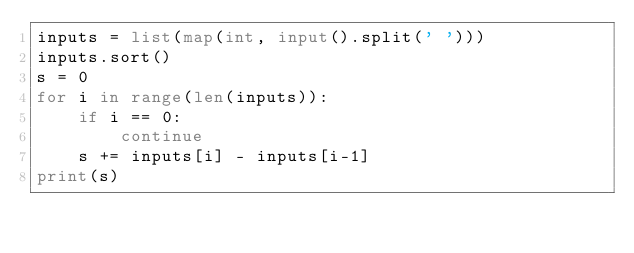<code> <loc_0><loc_0><loc_500><loc_500><_Python_>inputs = list(map(int, input().split(' ')))
inputs.sort()
s = 0
for i in range(len(inputs)):
    if i == 0:
        continue
    s += inputs[i] - inputs[i-1]
print(s)
</code> 